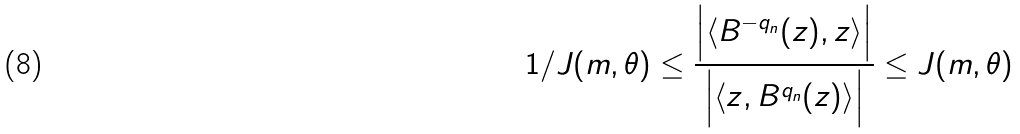Convert formula to latex. <formula><loc_0><loc_0><loc_500><loc_500>1 / J ( m , \theta ) \leq \frac { \Big { | } \langle { B } ^ { - q _ { n } } ( z ) , z \rangle \Big { | } } { \Big { | } \langle z , { B } ^ { q _ { n } } ( z ) \rangle \Big { | } } \leq J ( m , \theta )</formula> 